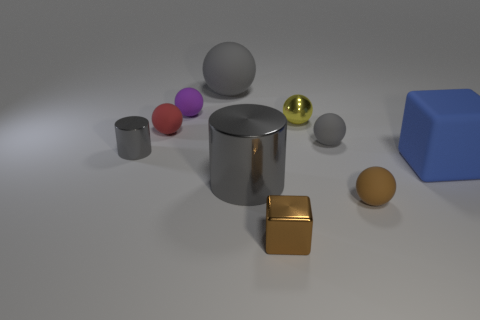Is there a blue thing that has the same size as the purple matte object?
Offer a terse response. No. What is the shape of the red rubber thing that is the same size as the yellow metal ball?
Offer a very short reply. Sphere. How many other objects are there of the same color as the big ball?
Your answer should be compact. 3. There is a tiny thing that is in front of the small yellow ball and behind the small gray rubber object; what shape is it?
Keep it short and to the point. Sphere. Are there any brown matte balls that are in front of the gray thing to the right of the tiny brown thing that is on the left side of the yellow thing?
Provide a short and direct response. Yes. How many other objects are the same material as the large gray cylinder?
Provide a short and direct response. 3. What number of small gray matte balls are there?
Make the answer very short. 1. What number of objects are either red rubber things or tiny matte spheres behind the large blue matte block?
Your response must be concise. 3. Is there anything else that has the same shape as the blue rubber object?
Your answer should be very brief. Yes. There is a cylinder that is to the right of the purple sphere; is it the same size as the big blue matte block?
Provide a short and direct response. Yes. 